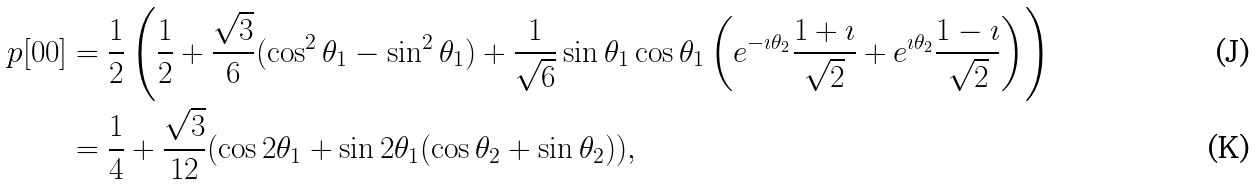Convert formula to latex. <formula><loc_0><loc_0><loc_500><loc_500>p [ 0 0 ] & = \frac { 1 } { 2 } \left ( \frac { 1 } { 2 } + \frac { \sqrt { 3 } } { 6 } ( \cos ^ { 2 } \theta _ { 1 } - \sin ^ { 2 } \theta _ { 1 } ) + \frac { 1 } { \sqrt { 6 } } \sin \theta _ { 1 } \cos \theta _ { 1 } \left ( e ^ { - \imath \theta _ { 2 } } \frac { 1 + \imath } { \sqrt { 2 } } + e ^ { \imath \theta _ { 2 } } \frac { 1 - \imath } { \sqrt { 2 } } \right ) \right ) \\ & = \frac { 1 } { 4 } + \frac { \sqrt { 3 } } { 1 2 } ( \cos 2 \theta _ { 1 } + \sin 2 \theta _ { 1 } ( \cos \theta _ { 2 } + \sin \theta _ { 2 } ) ) ,</formula> 